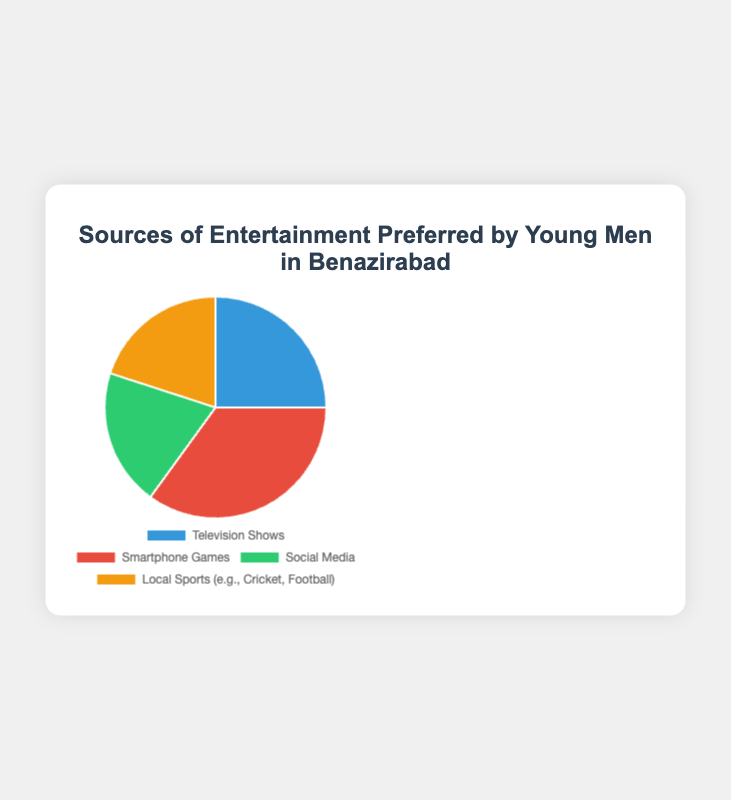What source of entertainment is preferred the most by young men in Benazirabad? Look at the data percentages in the pie chart. The highest percentage represents the most preferred source. Smartphone Games has the highest percentage at 35%.
Answer: Smartphone Games Which two sources of entertainment have equal preference among young men in Benazirabad? Refer to the data percentages in the pie chart. Check for the sources with the same percentages. Social Media and Local Sports both have 20%.
Answer: Social Media and Local Sports What is the total percentage of young men in Benazirabad who prefer either Television Shows or Local Sports? Add the percentages for Television Shows and Local Sports. Television Shows is 25%, and Local Sports is 20%. The total is 25% + 20% = 45%.
Answer: 45% What is the difference in the percentage of young men who prefer Smartphone Games versus those who prefer Social Media? Subtract the percentage for Social Media from the percentage for Smartphone Games. Smartphone Games is 35%, and Social Media is 20%. The difference is 35% - 20% = 15%.
Answer: 15% What percentage of young men in Benazirabad prefer sources of entertainment other than Social Media and Local Sports? Subtract the combined percentage of Social Media and Local Sports from 100%. Social Media and Local Sports each have 20%, so combined is 40%. 100% - 40% = 60%.
Answer: 60% Which segment in the pie chart is represented by the blue color? Look at the segment color in the pie chart and match it to the data labels provided in the code. The blue color corresponds to Television Shows.
Answer: Television Shows How much more popular are Smartphone Games compared to Television Shows among young men in Benazirabad? Subtract the percentage for Television Shows from the percentage for Smartphone Games. Smartphone Games is 35%, and Television Shows is 25%. The difference is 35% - 25% = 10%.
Answer: 10% If you were to combine the preferences for Social Media and Local Sports, what fraction of the total would they represent? Add the percentages for Social Media and Local Sports and convert the sum to a fraction of 100%. Social Media is 20%, and Local Sports is 20%. Combined is 20% + 20% = 40%. As a fraction of 100%, this is 40/100 or 2/5.
Answer: 2/5 